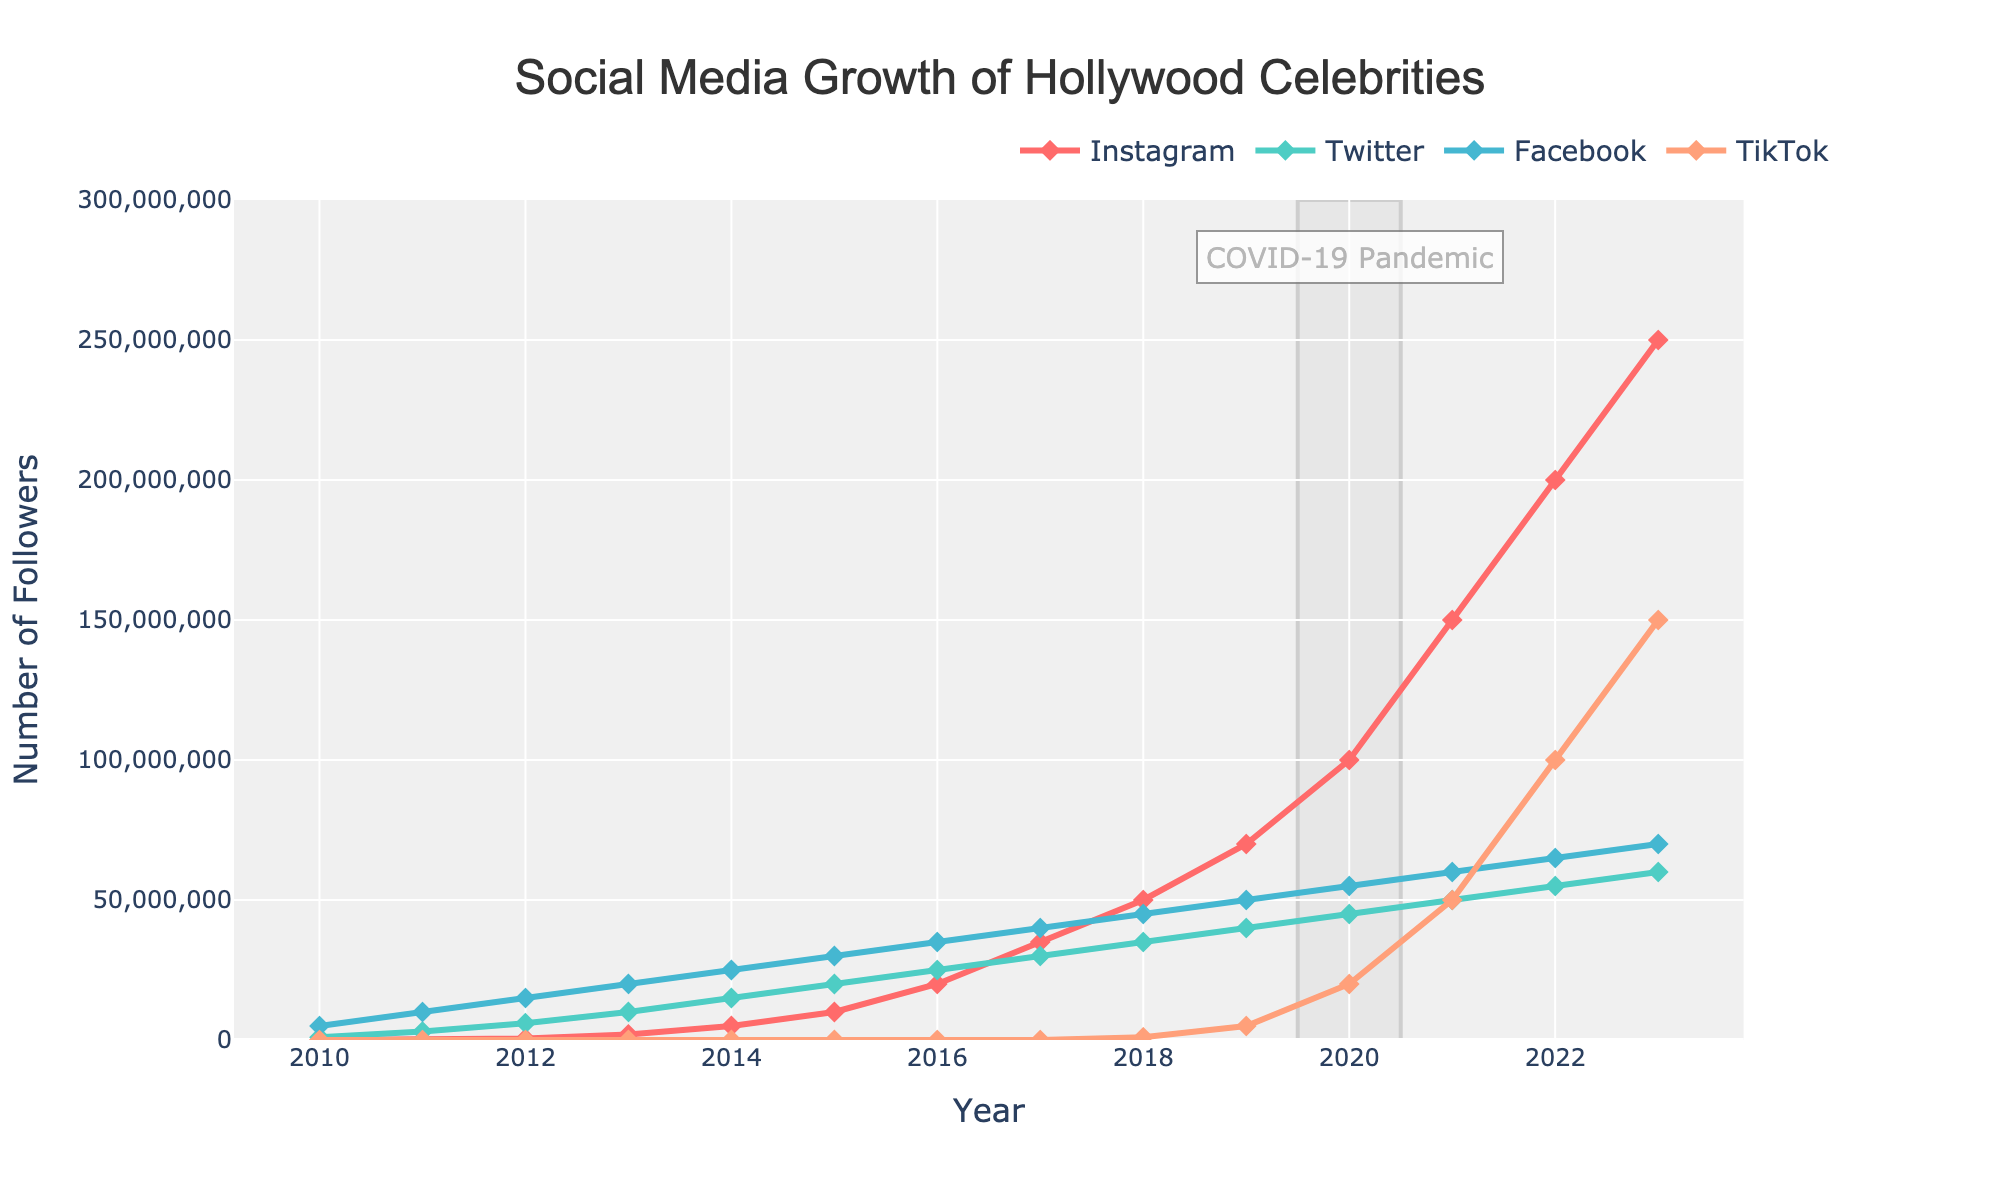What is the platform with the highest number of followers in 2023? Look at the endpoint values of each line in the year 2023. Compare the values for each platform and identify the highest one, which is Instagram with 250,000,000 followers.
Answer: Instagram Which platform showed the fastest growth from 2018 to 2020? Compare the slopes of the lines from 2018 to 2020. Instagram's follower count increased from 50,000,000 to 100,000,000, which is a 50,000,000 increase. Comparing to other platforms, Instagram's rise is the steepest.
Answer: Instagram How much did the total number of followers on Instagram grow from 2010 to 2023? Calculate the difference in values for Instagram between 2023 (250,000,000) and 2010 (0).
Answer: 250,000,000 Which social media platform had no growth until 2018? Look at the lines and identify which one remains flat until 2018. TikTok doesn't show any follower numbers until 2018.
Answer: TikTok In which year did Facebook reach 40,000,000 followers? Observe the graph and find the year where the line for Facebook (green) intersects the 40,000,000 followers mark. Facebook reached 40,000,000 followers in 2017.
Answer: 2017 What is the combined total number of followers for all platforms in 2022? Add the individual follower numbers for Instagram (200,000,000), Twitter (55,000,000), Facebook (65,000,000), and TikTok (100,000,000). The sum is 420,000,000 followers.
Answer: 420,000,000 Which platform experienced a jump in followers starting in 2020? Check which line shows a significant steepness increase starting from 2020. TikTok went from 5,000,000 (2019) to 20,000,000 (2020), highlighting a notable jump.
Answer: TikTok How did Twitter's follower growth between 2013 and 2016 compare to Facebook's growth in the same period? Calculate the difference in follower counts for Twitter (25,000,000 - 10,000,000 = 15,000,000) and Facebook (35,000,000 - 20,000,000 = 15,000,000). Both experienced the same growth of 15,000,000 followers.
Answer: Equal growth Which year did Instagram surpass Facebook in terms of total followers? Identify the year in which the follower count for Instagram (red line) exceeds that of Facebook (green line). This occurs between 2020 and 2021.
Answer: 2021 What is the average number of followers for Instagram in the first five years shown (2010-2014)? Sum the Instagram followers for 2010-2014 [(0 + 0 + 500,000 + 2,000,000 + 5,000,000) = 7,500,000] and divide by 5. The average number of Instagram followers is 1,500,000.
Answer: 1,500,000 